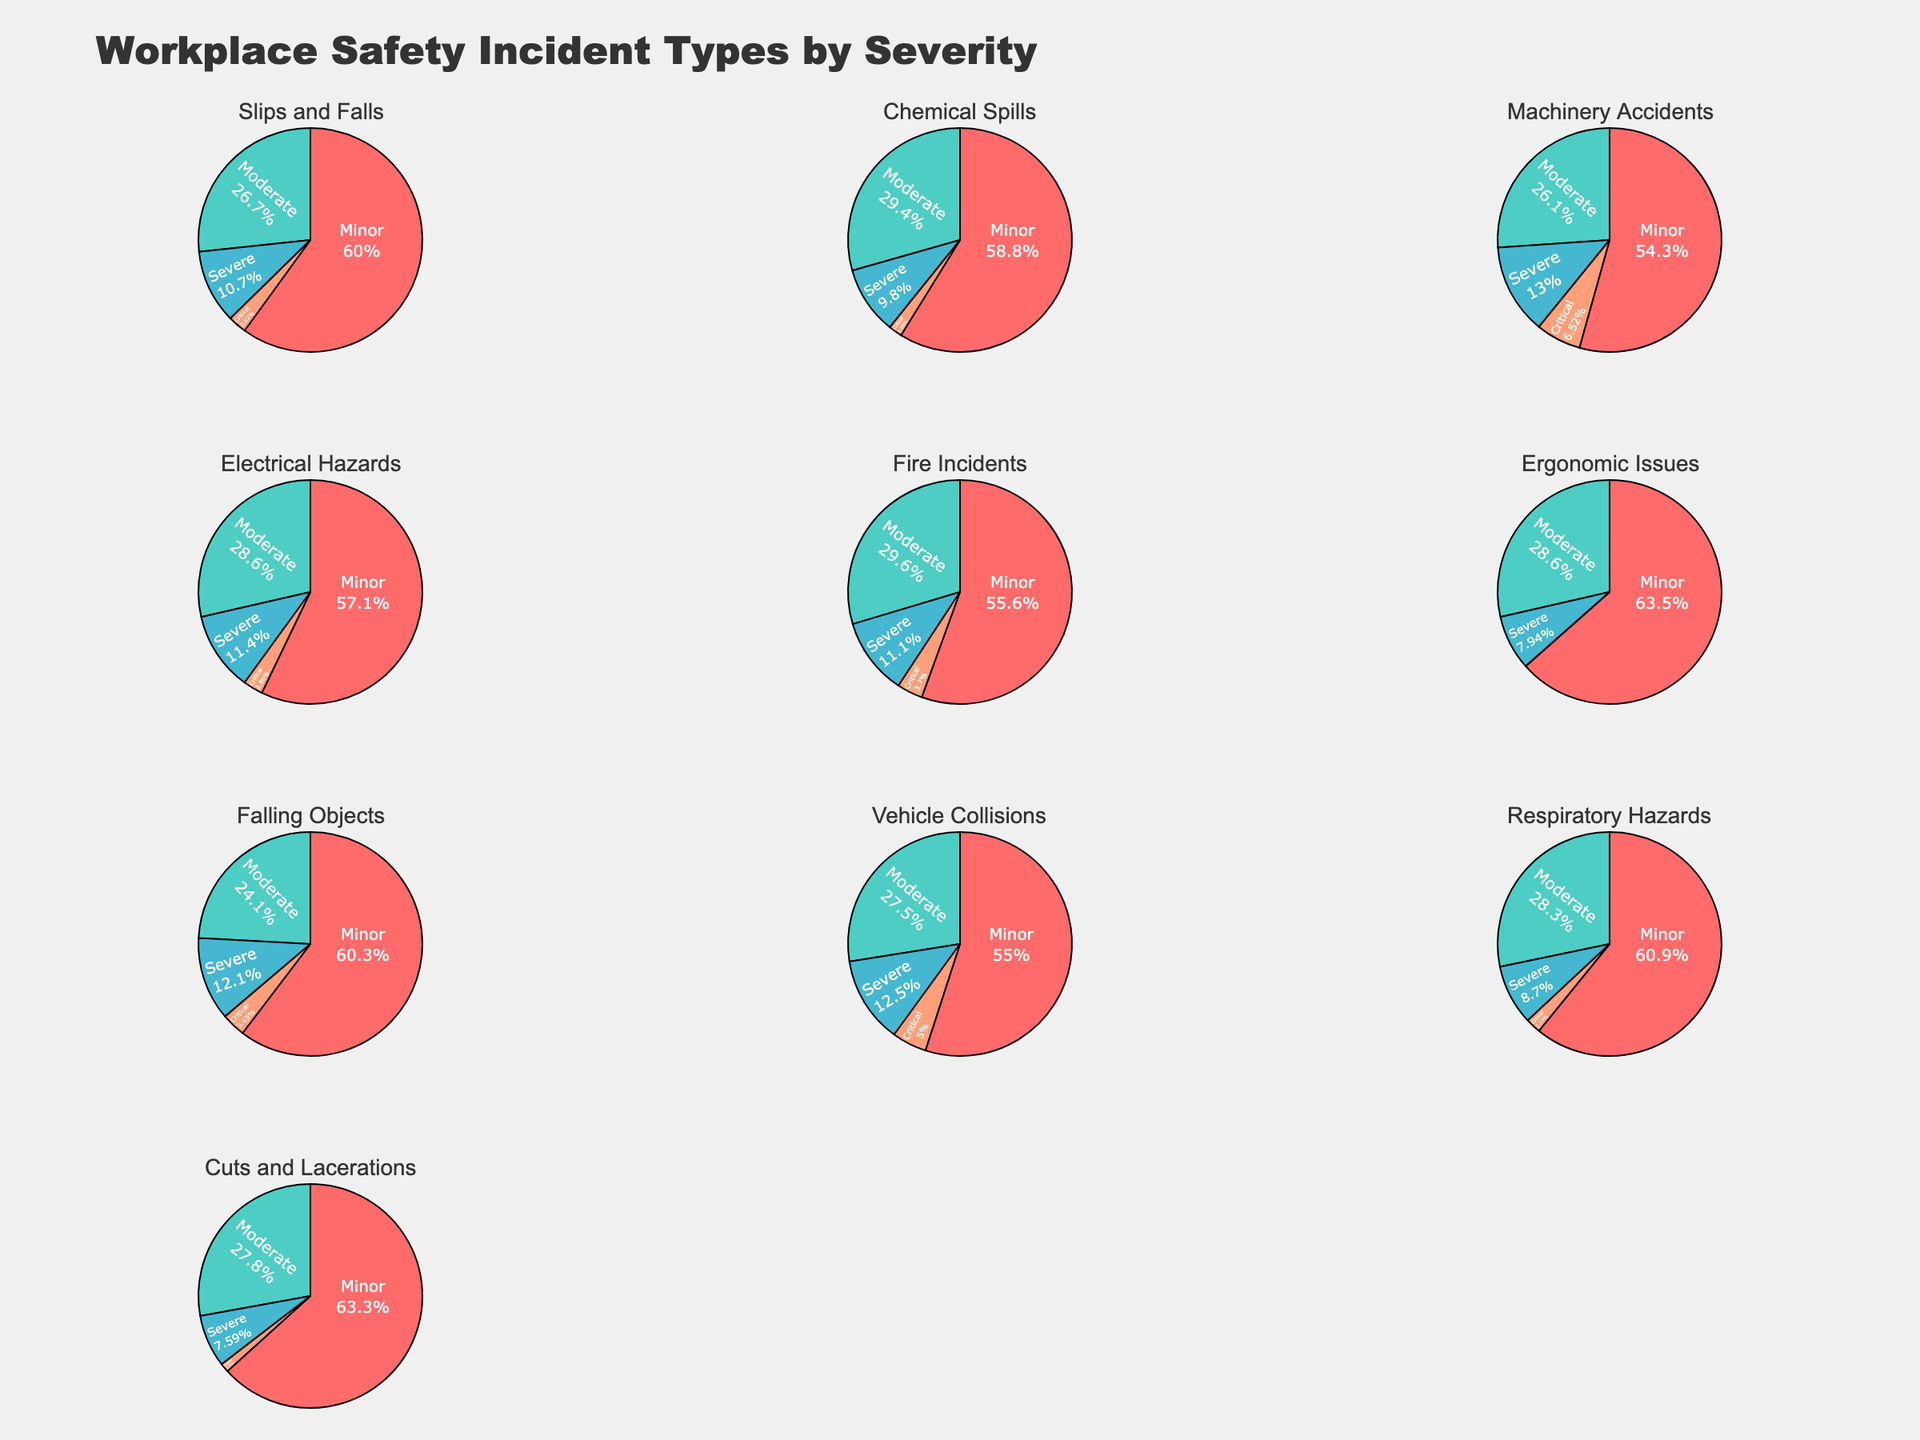What is the title of the figure? The title of the figure is usually displayed at the top and provides an overview of what the figure represents. It reads "Workplace Safety Incident Types by Severity" which tells us this figure categorizes different incident types and their severity.
Answer: Workplace Safety Incident Types by Severity Which incident type has the highest number of minor incidents? The pie chart for each incident type shows the number of minor incidents as the largest section when it has the highest value. "Cuts and Lacerations" has the largest share labeled 'Minor' among all, indicating 50 minor incidents.
Answer: Cuts and Lacerations What are the colors used in the pie charts? The figure uses distinct colors for the different slices in each pie chart. The primary colors identifiable are various shades like red, teal, blue, salmon, green, pink, purple, and brown. These colors help differentiate between the different severity levels.
Answer: Different shades of red, teal, blue, salmon, green, pink, purple, and brown Which incident type has the smallest proportion of critical incidents? For critical incidents, the pie charts with the smallest or zero critical incident slices will be examined. "Ergonomic Issues" has a negligible or non-existent critical segment, indicating the smallest amount for critical incidents at 0.
Answer: Ergonomic Issues What is the total count of severe incidents across all types? To find the total count, sum up all the severe incidents from each pie chart. The values are (8+5+6+4+3+5+7+5+4+6) = 53.
Answer: 53 Which incident type has equal counts of severe and critical incidents? By observing the segments of pie charts, we find "Machinery Accidents" and "Vehicle Collisions" each contain 6 severe and 3 critical incidents respectively.
Answer: Machinery Accidents On comparing moderate incidents, which is higher: Chemical Spills or Electrical Hazards? By comparing the pie chart segments labeled moderate for both Chemical Spills and Electrical Hazards, Chemical Spills has 15 while Electrical Hazards has 10.
Answer: Chemical Spills What is the combined total of minor and moderate incidents for Slips and Falls? Adding the values of minor and moderate incidents for Slips and Falls: 45 (minor) + 20 (moderate) = 65
Answer: 65 Among all incident types, which one has the lowest count of minor incidents? Observing the minor incident sections in each pie chart, "Fire Incidents" subsector appears to have the smallest count of 15.
Answer: Fire Incidents 